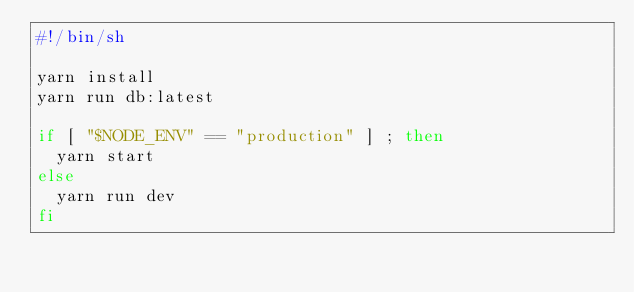<code> <loc_0><loc_0><loc_500><loc_500><_Bash_>#!/bin/sh

yarn install
yarn run db:latest

if [ "$NODE_ENV" == "production" ] ; then
  yarn start
else
  yarn run dev
fi
</code> 